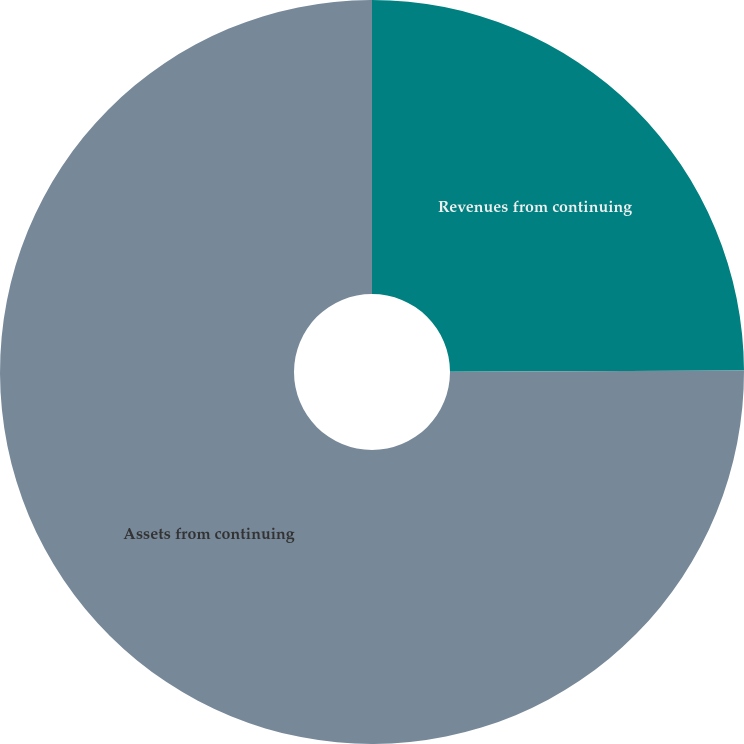<chart> <loc_0><loc_0><loc_500><loc_500><pie_chart><fcel>Revenues from continuing<fcel>Assets from continuing<nl><fcel>24.94%<fcel>75.06%<nl></chart> 